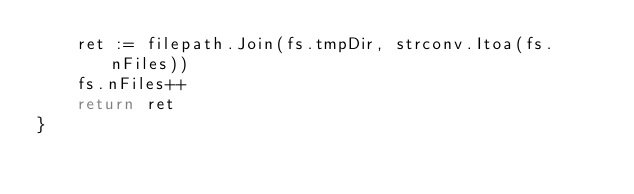Convert code to text. <code><loc_0><loc_0><loc_500><loc_500><_Go_>	ret := filepath.Join(fs.tmpDir, strconv.Itoa(fs.nFiles))
	fs.nFiles++
	return ret
}
</code> 